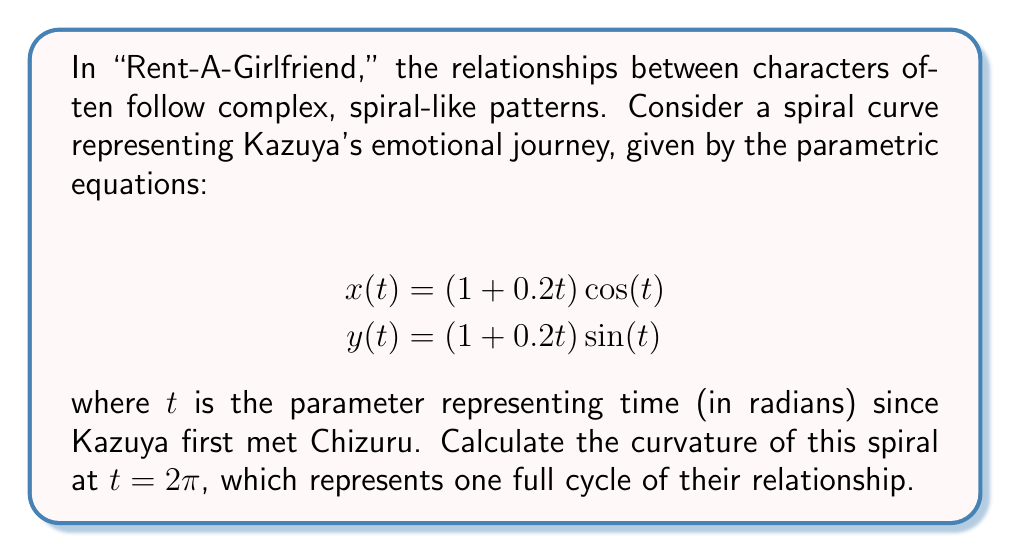Can you answer this question? To find the curvature of a parametric curve, we'll use the formula:

$$\kappa = \frac{|x'y'' - y'x''|}{(x'^2 + y'^2)^{3/2}}$$

Let's proceed step by step:

1) First, we need to find $x'(t)$, $y'(t)$, $x''(t)$, and $y''(t)$:

   $$x'(t) = 0.2\cos(t) - (1+0.2t)\sin(t)$$
   $$y'(t) = 0.2\sin(t) + (1+0.2t)\cos(t)$$
   $$x''(t) = -0.4\sin(t) - (1+0.2t)\cos(t) - 0.2\sin(t)$$
   $$y''(t) = 0.4\cos(t) - (1+0.2t)\sin(t) + 0.2\cos(t)$$

2) Now, let's evaluate these at $t = 2\pi$:

   $$x'(2\pi) = 0.2\cos(2\pi) - (1+0.4\pi)\sin(2\pi) = 0.2$$
   $$y'(2\pi) = 0.2\sin(2\pi) + (1+0.4\pi)\cos(2\pi) = 1+0.4\pi$$
   $$x''(2\pi) = -0.4\sin(2\pi) - (1+0.4\pi)\cos(2\pi) - 0.2\sin(2\pi) = -(1+0.4\pi)$$
   $$y''(2\pi) = 0.4\cos(2\pi) - (1+0.4\pi)\sin(2\pi) + 0.2\cos(2\pi) = 0.6$$

3) Next, we calculate the numerator of the curvature formula:

   $$|x'y'' - y'x''| = |0.2(0.6) - (1+0.4\pi)(-(1+0.4\pi))| = (1+0.4\pi)^2 + 0.12$$

4) For the denominator, we calculate:

   $$(x'^2 + y'^2)^{3/2} = (0.2^2 + (1+0.4\pi)^2)^{3/2}$$

5) Finally, we can compute the curvature:

   $$\kappa = \frac{(1+0.4\pi)^2 + 0.12}{(0.2^2 + (1+0.4\pi)^2)^{3/2}}$$
Answer: $$\kappa = \frac{(1+0.4\pi)^2 + 0.12}{(0.2^2 + (1+0.4\pi)^2)^{3/2}} \approx 0.3953$$ 